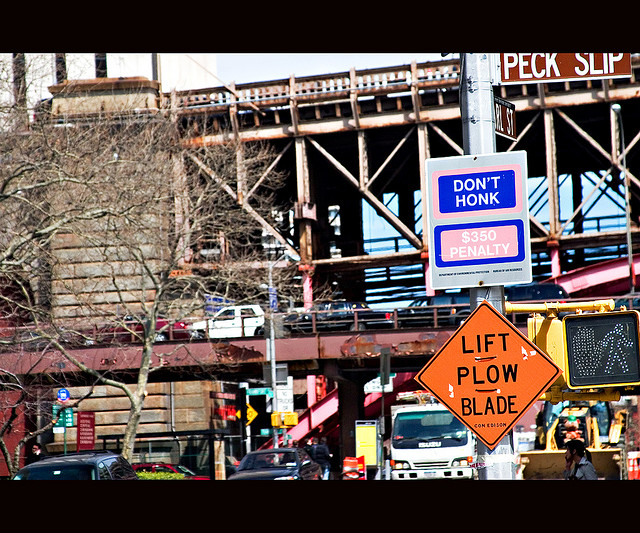<image>How many people are in their vehicles? It is unknown how many people are in their vehicles. How many people are in their vehicles? I don't know how many people are in their vehicles. It can be 0, 1, 3 or more. 